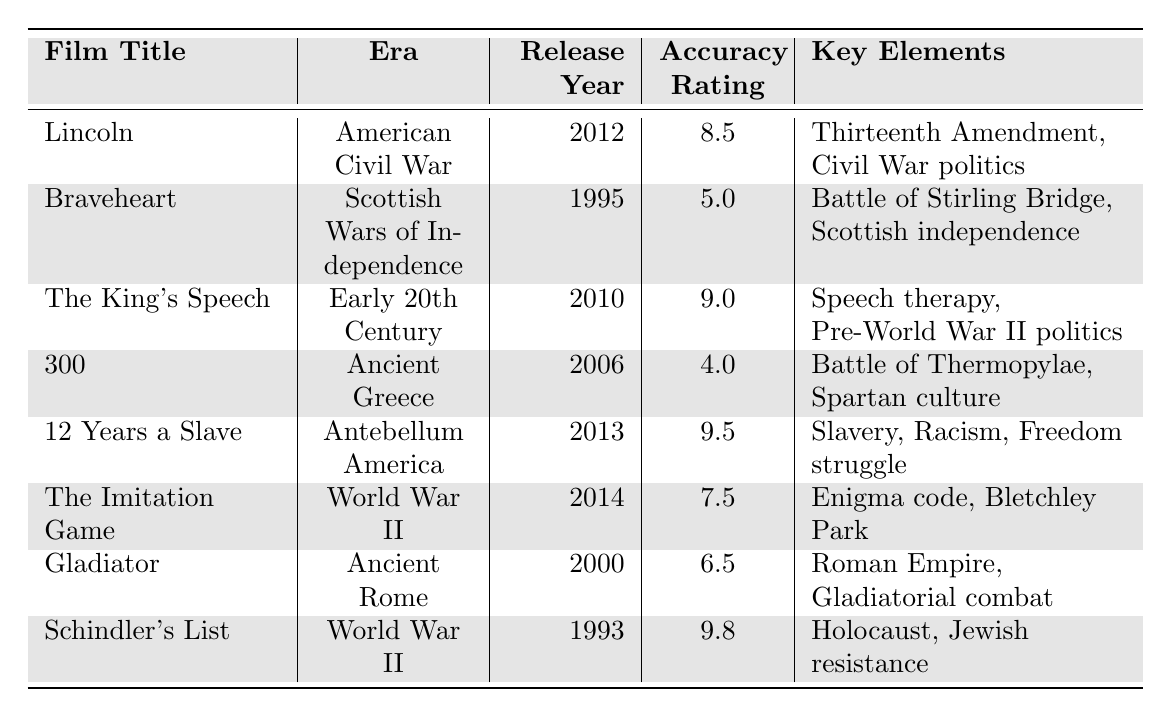What is the accuracy rating of the film "Braveheart"? The table lists "Braveheart" under the film title column, and its accuracy rating is shown in the corresponding cell, which is 5.0.
Answer: 5.0 Which film has the highest accuracy rating? By examining the accuracy ratings, "Schindler's List" has the highest rating at 9.8.
Answer: Schindler's List How many films were released in the 21st century? The films released in the 21st century are "Lincoln" (2012), "The King's Speech" (2010), "12 Years a Slave" (2013), "The Imitation Game" (2014), and "Gladiator" (2000). Counting these gives a total of 5 films.
Answer: 5 Is there a film that portrays a higher accuracy than both "The Imitation Game" and "Gladiator"? Comparing the accuracy ratings, "Schindler's List" (9.8), "12 Years a Slave" (9.5), and "The King's Speech" (9.0) all have higher accuracy ratings than both "The Imitation Game" (7.5) and "Gladiator" (6.5).
Answer: Yes What is the average accuracy rating of films set during World War II? The films set in World War II are "The Imitation Game" (7.5) and "Schindler's List" (9.8). To find the average, add the two ratings (7.5 + 9.8 = 17.3) and divide by 2, resulting in an average of 8.65.
Answer: 8.65 Which film features the historical figure Solomon Northup? The film featuring Solomon Northup is "12 Years a Slave", as listed in the main historical figures column for that film.
Answer: 12 Years a Slave What is the difference between the accuracy ratings of "300" and "Lincoln"? "300" has an accuracy rating of 4.0 and "Lincoln" has 8.5. The difference is calculated by subtracting the lower from the higher: 8.5 - 4.0 = 4.5.
Answer: 4.5 List all key elements mentioned for the film "The King's Speech". The table specifies the key elements for "The King's Speech" as "Speech therapy, Pre-World War II politics, Royal family dynamics".
Answer: Speech therapy, Pre-World War II politics, Royal family dynamics How many films focus on Ancient history, and what are their titles? The films focusing on Ancient history are "300" and "Gladiator". Thus, there are 2 films in that category.
Answer: 2, 300 and Gladiator Was "The King's Speech" released before "Braveheart"? "The King's Speech" was released in 2010 and "Braveheart" in 1995. Since 2010 is after 1995, the answer is no.
Answer: No 